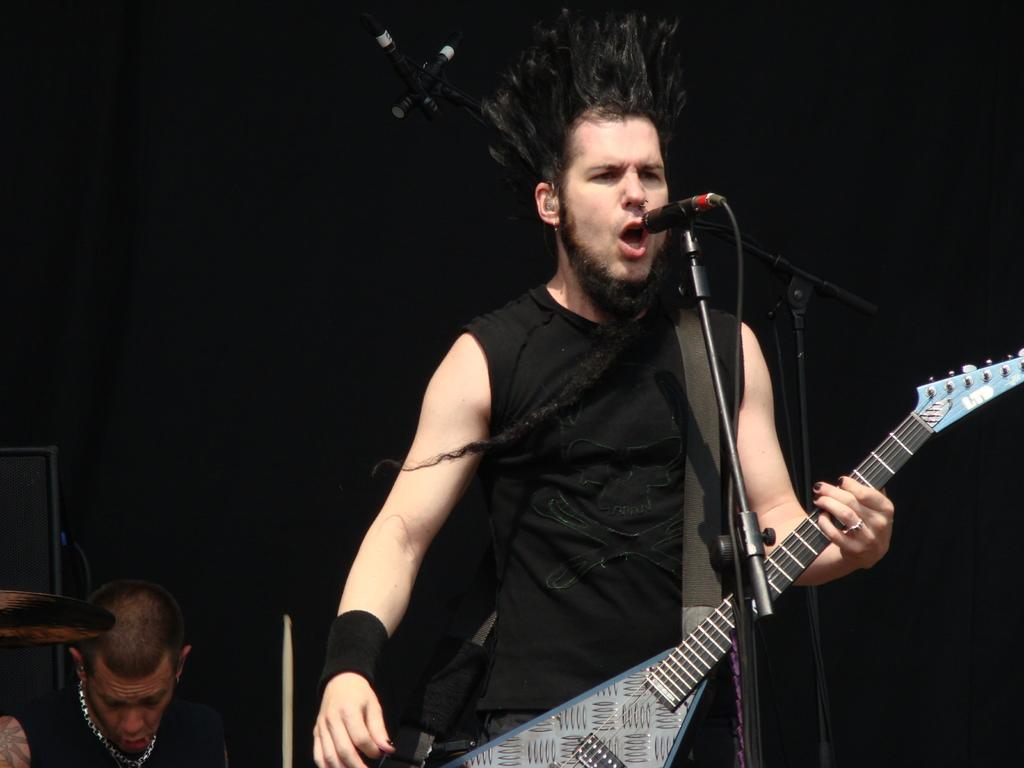What is the man in the image doing? The man is singing in the image. How is the man positioned while singing? The man is standing while singing. What instrument is the man holding? The man is holding a guitar in his hands. Can you describe the other person in the image? There is another man in the background of the image, and he is sitting. What type of key is the man using to create the music in the image? There is no key present in the image, and the man is using a guitar to create music. 